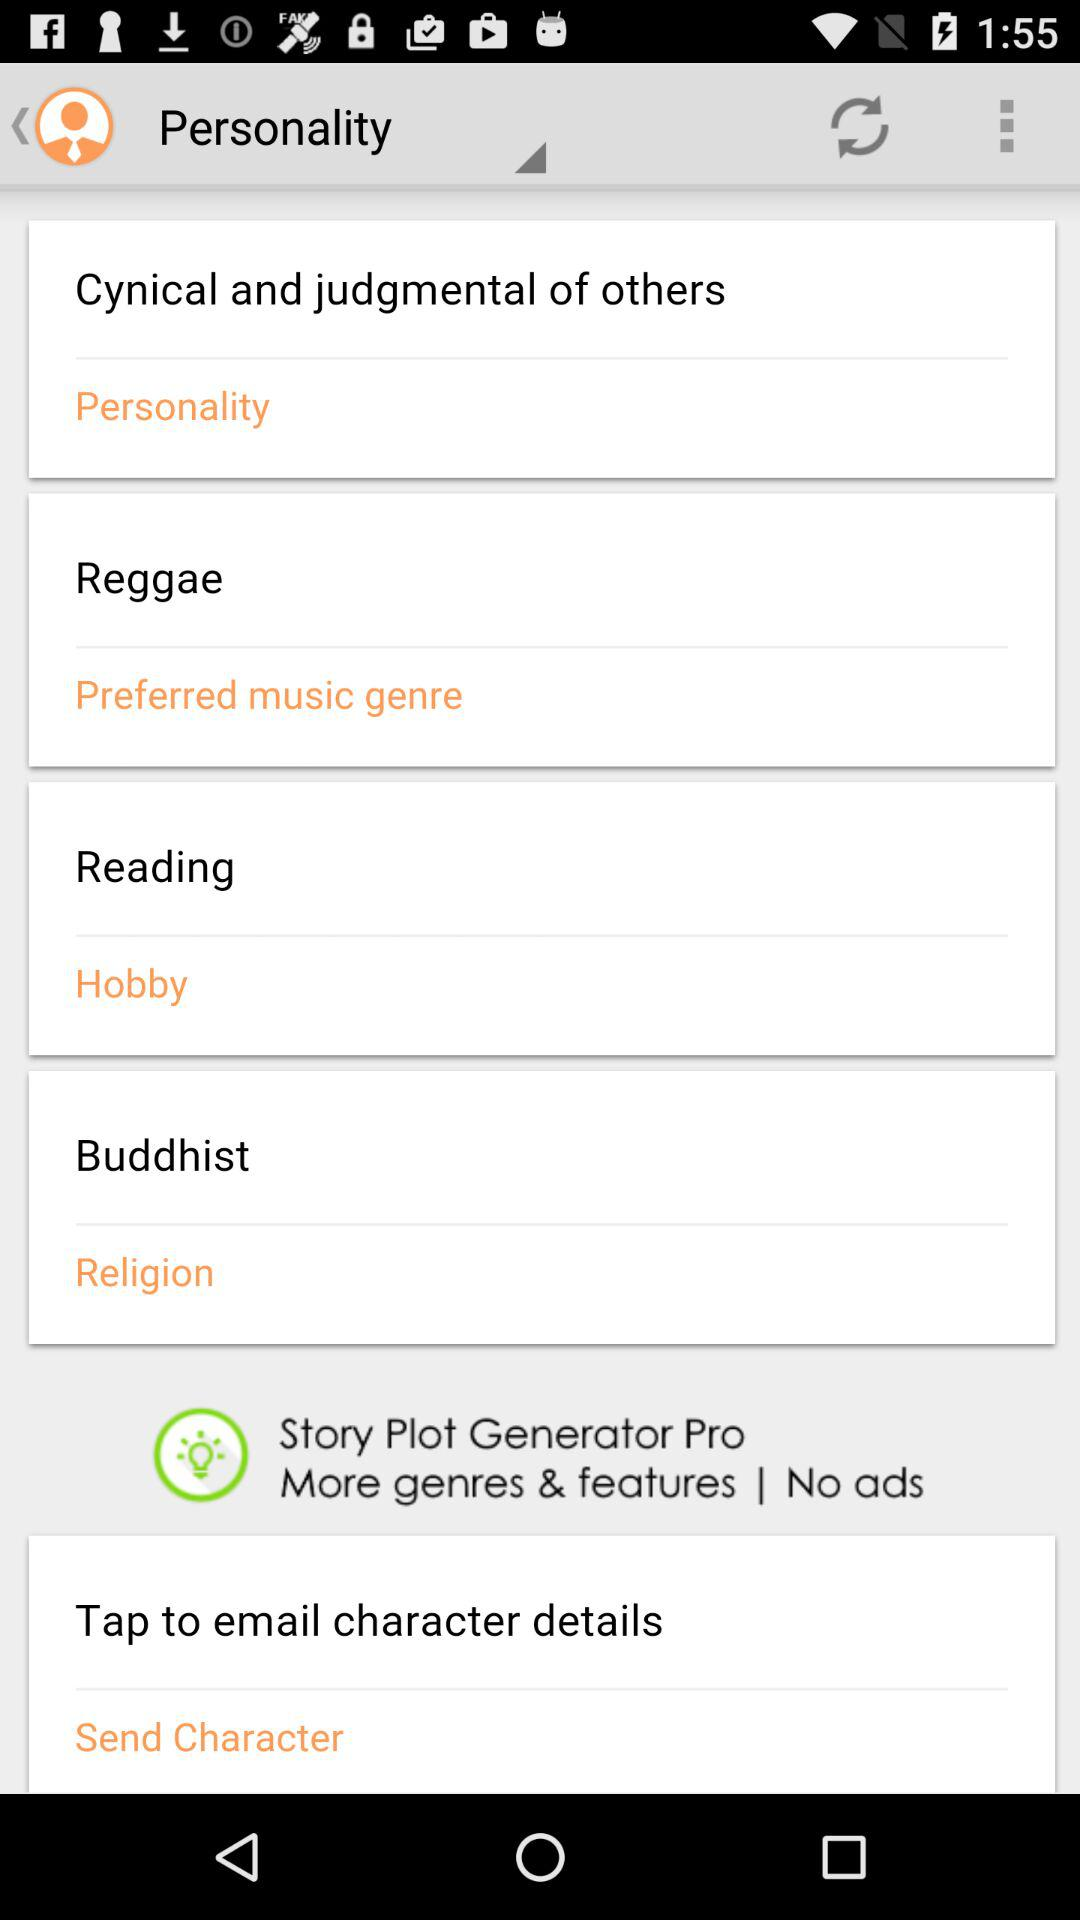What is the selected music genre? The selected music genre is reggae. 